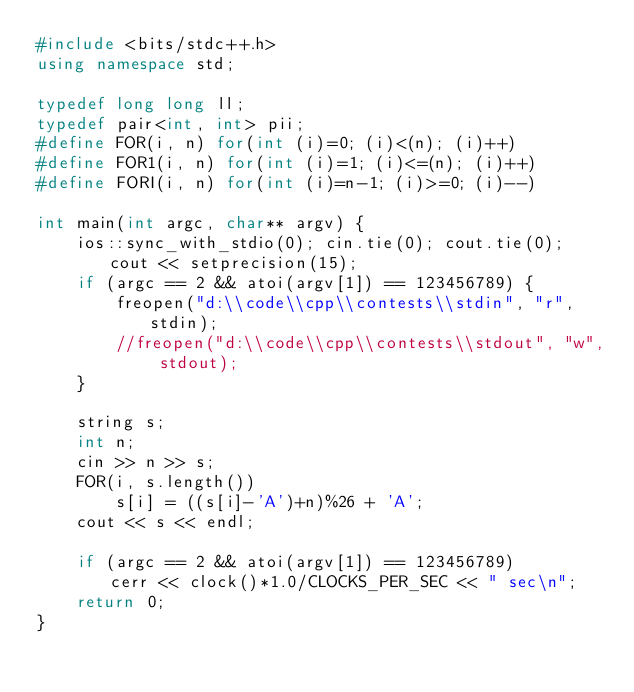Convert code to text. <code><loc_0><loc_0><loc_500><loc_500><_C++_>#include <bits/stdc++.h>
using namespace std;

typedef long long ll;
typedef pair<int, int> pii;
#define FOR(i, n) for(int (i)=0; (i)<(n); (i)++)
#define FOR1(i, n) for(int (i)=1; (i)<=(n); (i)++)
#define FORI(i, n) for(int (i)=n-1; (i)>=0; (i)--)

int main(int argc, char** argv) {
    ios::sync_with_stdio(0); cin.tie(0); cout.tie(0); cout << setprecision(15);
    if (argc == 2 && atoi(argv[1]) == 123456789) {
        freopen("d:\\code\\cpp\\contests\\stdin", "r", stdin);
        //freopen("d:\\code\\cpp\\contests\\stdout", "w", stdout);
    }

    string s;
    int n;
    cin >> n >> s;
    FOR(i, s.length())
        s[i] = ((s[i]-'A')+n)%26 + 'A';
    cout << s << endl;

    if (argc == 2 && atoi(argv[1]) == 123456789)        cerr << clock()*1.0/CLOCKS_PER_SEC << " sec\n";
    return 0;
}</code> 